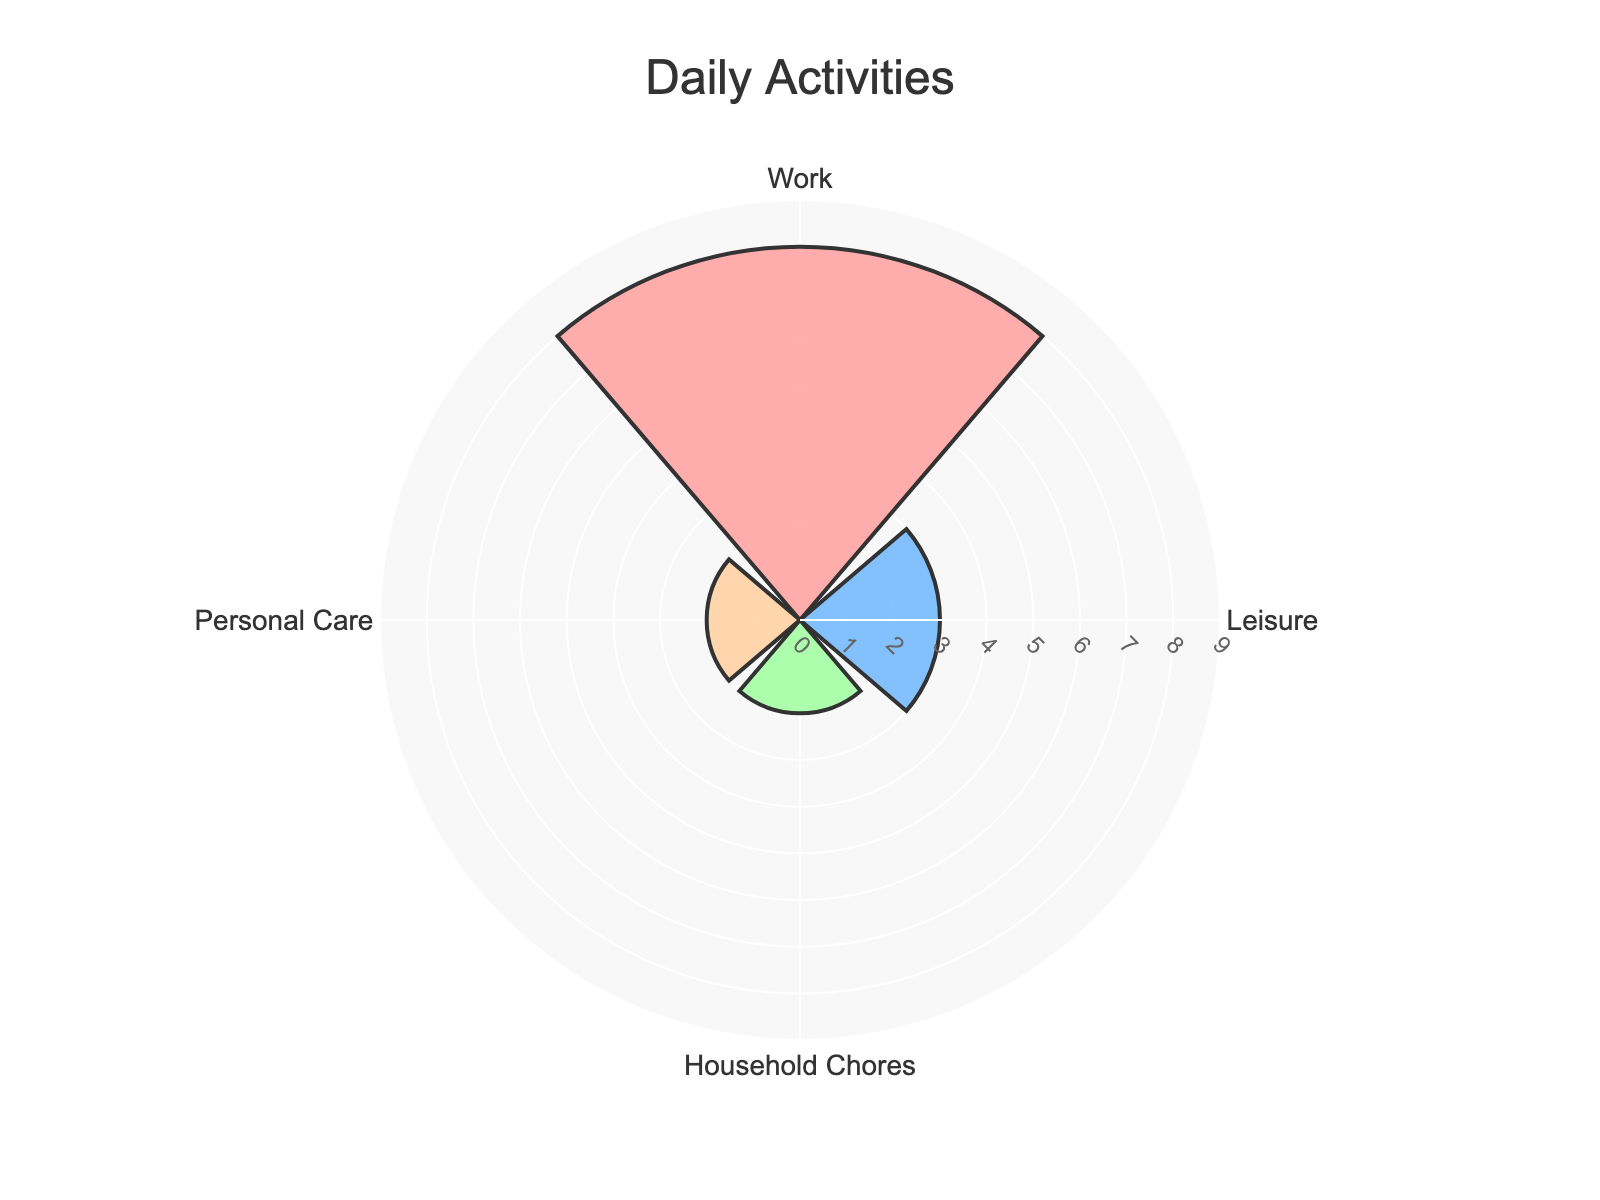What is the title of the chart? The title is usually written at the top of the chart. In this case, it reads "Daily Activities".
Answer: Daily Activities How many hours per day are spent on leisure activities? Find the segment labeled "Leisure", and you'll see it extends to the number 3 on the radial axis, indicating 3 hours.
Answer: 3 Which activity has the highest number of hours spent per day? Look at the length of each segment; the "Work" segment is the longest, reaching 8 hours.
Answer: Work What is the total number of hours spent on Household Chores and Personal Care combined? Add the hours for Household Chores (2 hours) and Personal Care (2 hours): 2 + 2 = 4 hours.
Answer: 4 Which two activities have the same number of hours spent per day? Compare the length of each segment. Both "Household Chores" and "Personal Care" segments reach up to 2 hours.
Answer: Household Chores and Personal Care What is the average number of hours spent on Leisure and Household Chores? Add the hours spent on Leisure and Household Chores (3 + 2 = 5) and divide by 2: 5 / 2 = 2.5.
Answer: 2.5 How much more time is spent on Work compared to Leisure? Subtract the hours of Leisure (3) from the hours of Work (8): 8 - 3 = 5 hours.
Answer: 5 What percentage of the total daily hours is spent on Personal Care? First, calculate the total hours spent on all activities: 8 (Work) + 3 (Leisure) + 2 (Household Chores) + 2 (Personal Care) = 15 hours. Then, divide the hours for Personal Care by the total hours and multiply by 100: (2 / 15) * 100 = 13.33%.
Answer: 13.33% If one were to decrease Work time by 2 hours, how much time would be left? Subtract 2 hours from the current Work hours: 8 - 2 = 6.
Answer: 6 